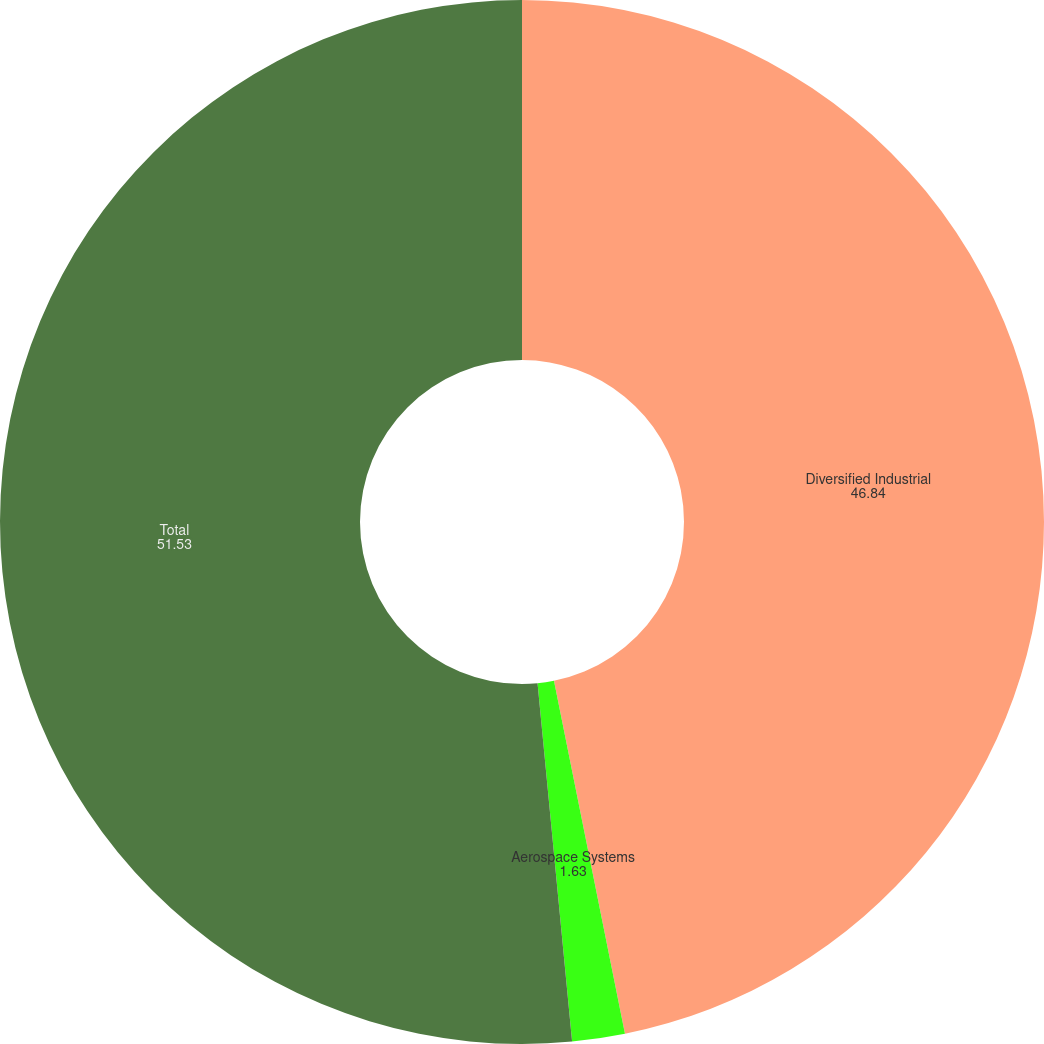Convert chart to OTSL. <chart><loc_0><loc_0><loc_500><loc_500><pie_chart><fcel>Diversified Industrial<fcel>Aerospace Systems<fcel>Total<nl><fcel>46.84%<fcel>1.63%<fcel>51.53%<nl></chart> 